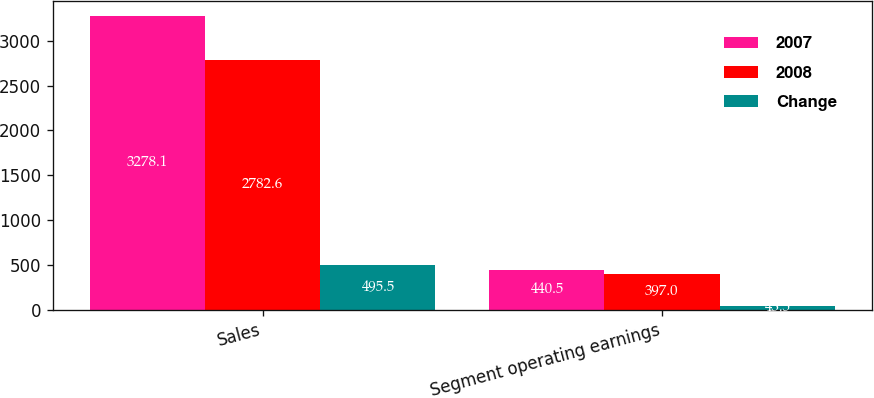Convert chart. <chart><loc_0><loc_0><loc_500><loc_500><stacked_bar_chart><ecel><fcel>Sales<fcel>Segment operating earnings<nl><fcel>2007<fcel>3278.1<fcel>440.5<nl><fcel>2008<fcel>2782.6<fcel>397<nl><fcel>Change<fcel>495.5<fcel>43.5<nl></chart> 